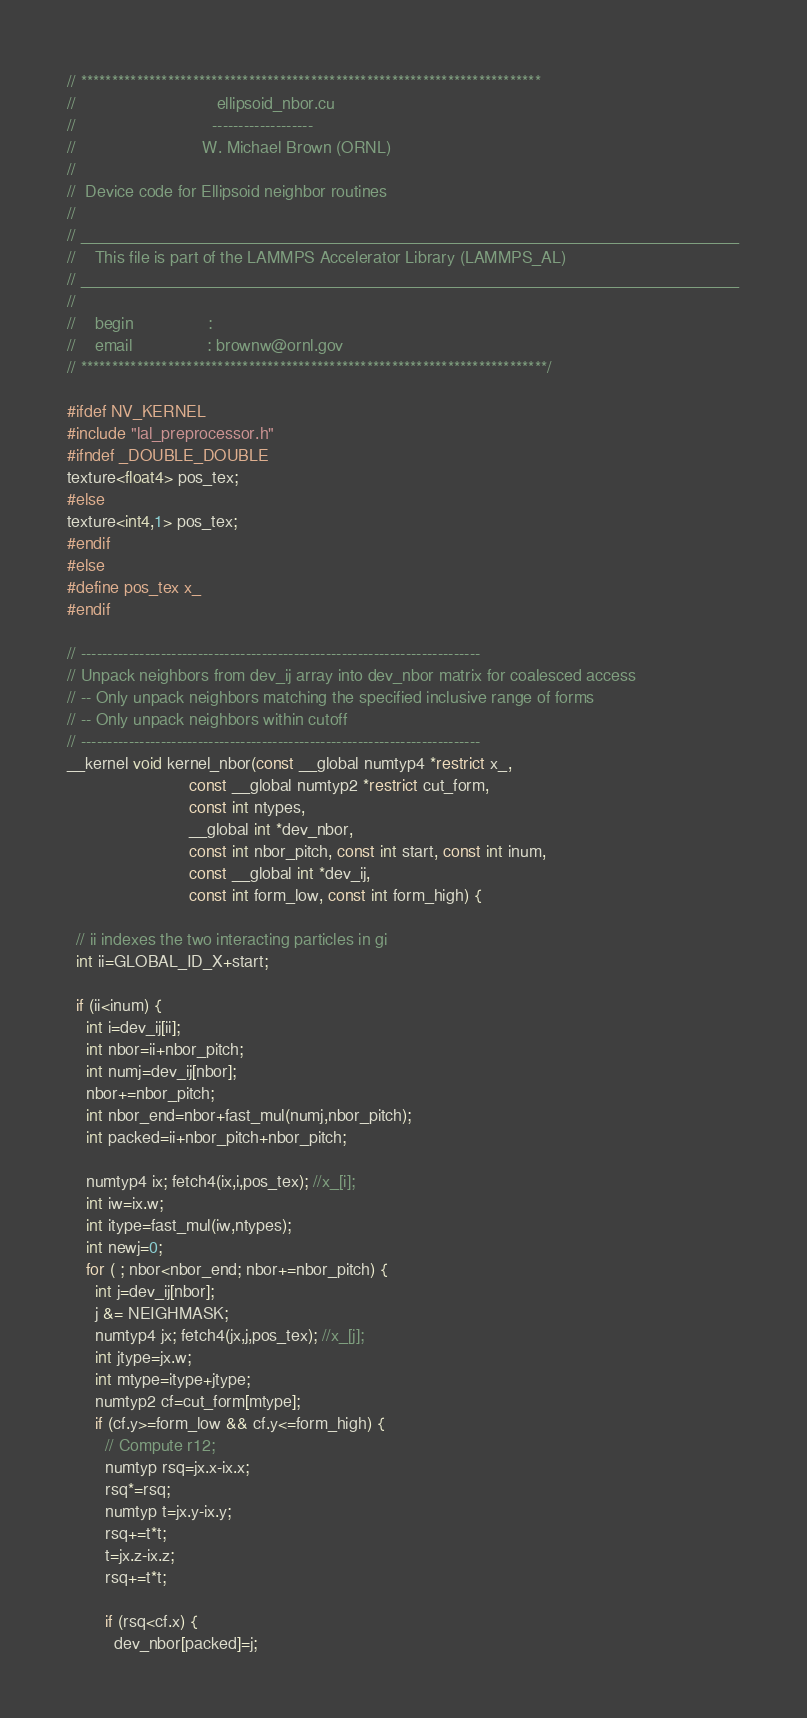<code> <loc_0><loc_0><loc_500><loc_500><_Cuda_>// **************************************************************************
//                              ellipsoid_nbor.cu
//                             -------------------
//                           W. Michael Brown (ORNL)
//
//  Device code for Ellipsoid neighbor routines
//
// __________________________________________________________________________
//    This file is part of the LAMMPS Accelerator Library (LAMMPS_AL)
// __________________________________________________________________________
//
//    begin                :
//    email                : brownw@ornl.gov
// ***************************************************************************/

#ifdef NV_KERNEL
#include "lal_preprocessor.h"
#ifndef _DOUBLE_DOUBLE
texture<float4> pos_tex;
#else
texture<int4,1> pos_tex;
#endif
#else
#define pos_tex x_
#endif

// ---------------------------------------------------------------------------
// Unpack neighbors from dev_ij array into dev_nbor matrix for coalesced access
// -- Only unpack neighbors matching the specified inclusive range of forms
// -- Only unpack neighbors within cutoff
// ---------------------------------------------------------------------------
__kernel void kernel_nbor(const __global numtyp4 *restrict x_,
                          const __global numtyp2 *restrict cut_form,
                          const int ntypes,
                          __global int *dev_nbor,
                          const int nbor_pitch, const int start, const int inum,
                          const __global int *dev_ij,
                          const int form_low, const int form_high) {

  // ii indexes the two interacting particles in gi
  int ii=GLOBAL_ID_X+start;

  if (ii<inum) {
    int i=dev_ij[ii];
    int nbor=ii+nbor_pitch;
    int numj=dev_ij[nbor];
    nbor+=nbor_pitch;
    int nbor_end=nbor+fast_mul(numj,nbor_pitch);
    int packed=ii+nbor_pitch+nbor_pitch;

    numtyp4 ix; fetch4(ix,i,pos_tex); //x_[i];
    int iw=ix.w;
    int itype=fast_mul(iw,ntypes);
    int newj=0;
    for ( ; nbor<nbor_end; nbor+=nbor_pitch) {
      int j=dev_ij[nbor];
      j &= NEIGHMASK;
      numtyp4 jx; fetch4(jx,j,pos_tex); //x_[j];
      int jtype=jx.w;
      int mtype=itype+jtype;
      numtyp2 cf=cut_form[mtype];
      if (cf.y>=form_low && cf.y<=form_high) {
        // Compute r12;
        numtyp rsq=jx.x-ix.x;
        rsq*=rsq;
        numtyp t=jx.y-ix.y;
        rsq+=t*t;
        t=jx.z-ix.z;
        rsq+=t*t;

        if (rsq<cf.x) {
          dev_nbor[packed]=j;</code> 